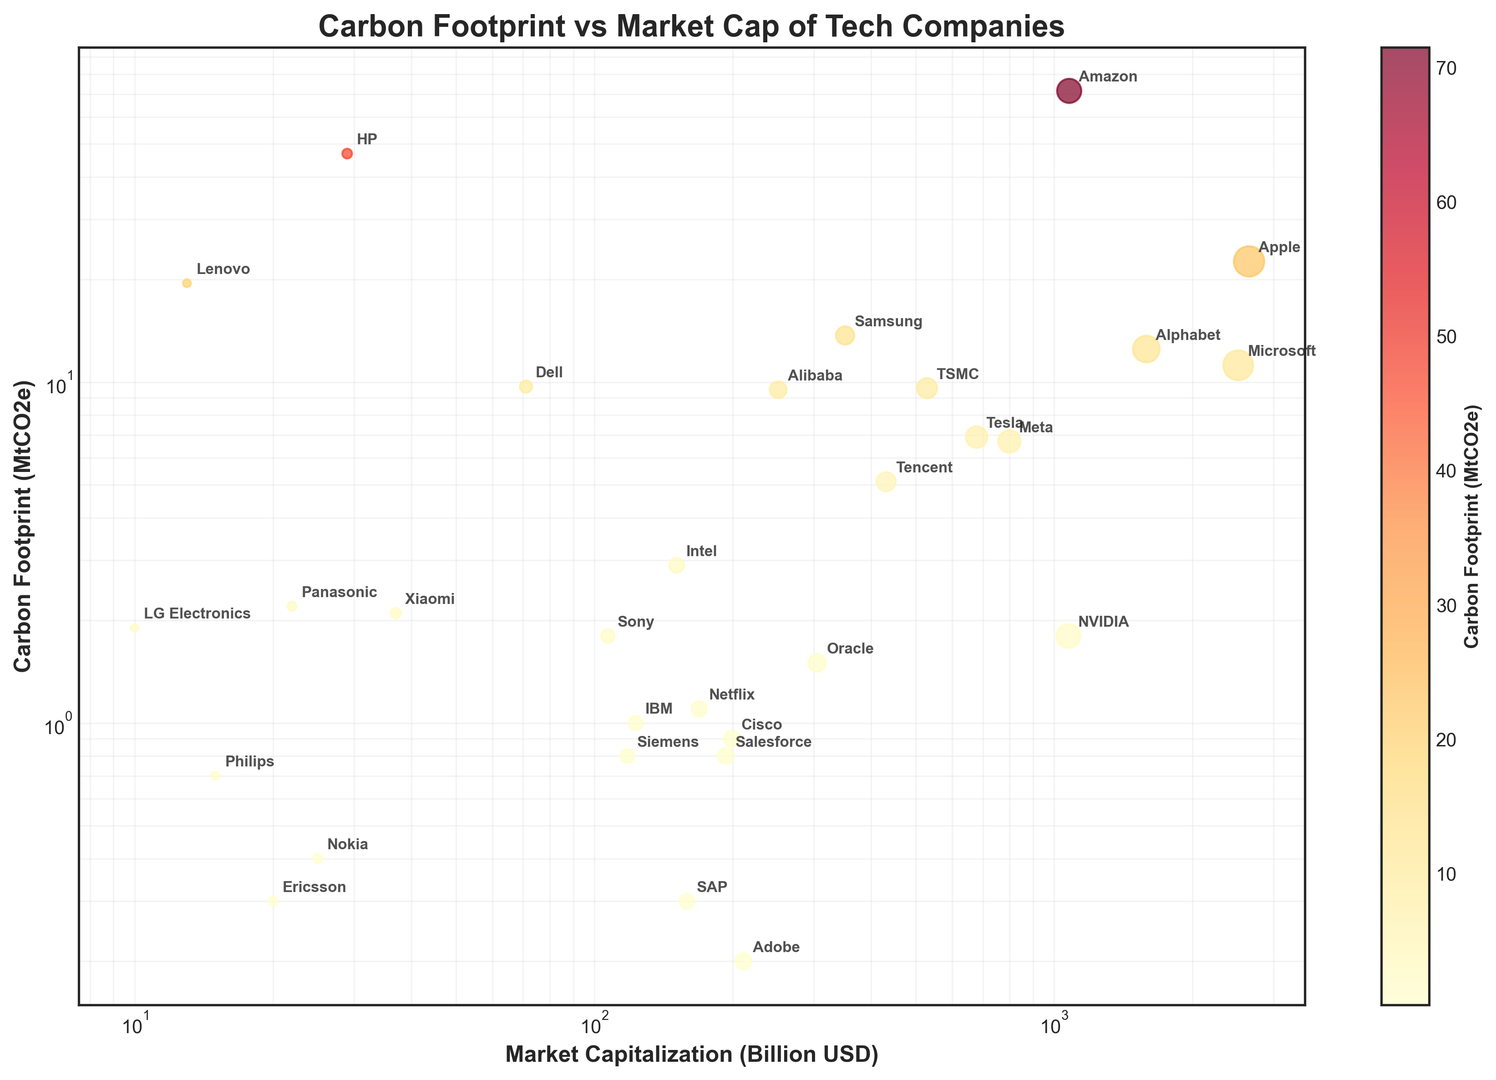Which company has the highest carbon footprint? Locate the company with the highest value on the y-axis representing Carbon Footprint (MtCO2e). Amazon has the highest carbon footprint, significantly higher than the others.
Answer: Amazon Which company has the smallest market capitalization? Find the company with the lowest value on the x-axis representing Market Capitalization (Billion USD). LG Electronics has the smallest market cap.
Answer: LG Electronics Which company has a similar market cap to Intel but a higher carbon footprint? Look for companies near Intel's x-position (151 Billion USD) but with a higher y-value. Dell has a higher carbon footprint with a similar market cap.
Answer: Dell What is the combined carbon footprint of Apple, Microsoft, and Alphabet? Sum the carbon footprints of Apple (22.6 MtCO2e), Microsoft (11.2 MtCO2e), and Alphabet (12.5 MtCO2e). The total is 22.6 + 11.2 + 12.5 = 46.3 MtCO2e.
Answer: 46.3 MtCO2e Which companies have a carbon footprint below 1.0 MtCO2e, and what are their combined market caps? Identify companies with a y-value below 1.0 (Adobe, SAP, Ericsson, Pinterest) and sum their market caps: 211 + 159 + 20 + 15 = 405 Billion USD.
Answer: 405 Billion USD Is there any company with a larger carbon footprint than Apple but a smaller market cap? Check for companies with y-values higher than Apple (22.6 MtCO2e) but x-values lower than Apple (2653 Billion USD). HP (46.8 MtCO2e, 29 Billion USD) and Lenovo (19.5 MtCO2e, 13 Billion USD) fit these criteria.
Answer: HP and Lenovo What is the ratio of the carbon footprint between Amazon and Dell? Divide Amazon's carbon footprint (71.5 MtCO2e) by Dell's carbon footprint (9.7 MtCO2e). The ratio is 71.5 / 9.7 ≈ 7.37.
Answer: 7.37 Which company with a market cap greater than 500 Billion USD has the lowest carbon footprint? Filter companies with x-values greater than 500 and find the one with the smallest y-value. NVIDIA has the smallest carbon footprint (1.8 MtCO2e).
Answer: NVIDIA How does the carbon footprint of Xiaomi compare to LG Electronics? Compare the y-values of Xiaomi (2.1 MtCO2e) and LG Electronics (1.9 MtCO2e). Xiaomi has a slightly higher carbon footprint.
Answer: Xiaomi Which company stands out due to its higher carbon footprint despite its lower market capitalization, indicated by a deeply saturated color? Spot the company with the most pronounced color indicating a high carbon footprint and a lower position on the x-axis. HP stands out for its high carbon footprint (46.8 MtCO2e) and lower market cap (29 Billion USD).
Answer: HP 